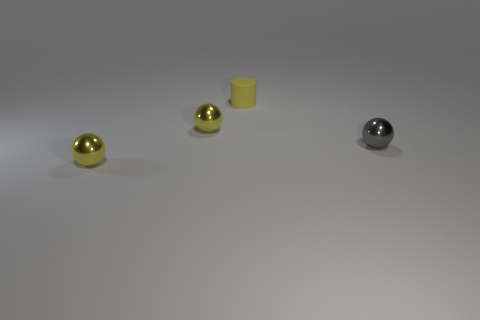Subtract all tiny yellow metallic spheres. How many spheres are left? 1 Add 1 small cyan rubber cylinders. How many objects exist? 5 Subtract all yellow balls. How many balls are left? 1 Subtract all balls. How many objects are left? 1 Subtract all cyan cylinders. How many yellow balls are left? 2 Subtract all small brown metallic things. Subtract all tiny yellow matte cylinders. How many objects are left? 3 Add 2 small objects. How many small objects are left? 6 Add 3 blue matte things. How many blue matte things exist? 3 Subtract 0 green blocks. How many objects are left? 4 Subtract 1 cylinders. How many cylinders are left? 0 